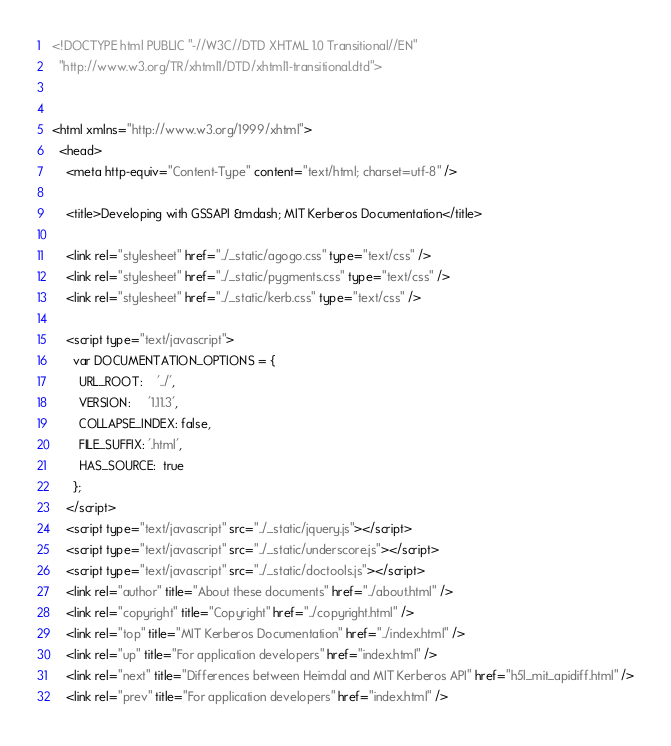Convert code to text. <code><loc_0><loc_0><loc_500><loc_500><_HTML_>

<!DOCTYPE html PUBLIC "-//W3C//DTD XHTML 1.0 Transitional//EN"
  "http://www.w3.org/TR/xhtml1/DTD/xhtml1-transitional.dtd">


<html xmlns="http://www.w3.org/1999/xhtml">
  <head>
    <meta http-equiv="Content-Type" content="text/html; charset=utf-8" />
    
    <title>Developing with GSSAPI &mdash; MIT Kerberos Documentation</title>
    
    <link rel="stylesheet" href="../_static/agogo.css" type="text/css" />
    <link rel="stylesheet" href="../_static/pygments.css" type="text/css" />
    <link rel="stylesheet" href="../_static/kerb.css" type="text/css" />
    
    <script type="text/javascript">
      var DOCUMENTATION_OPTIONS = {
        URL_ROOT:    '../',
        VERSION:     '1.11.3',
        COLLAPSE_INDEX: false,
        FILE_SUFFIX: '.html',
        HAS_SOURCE:  true
      };
    </script>
    <script type="text/javascript" src="../_static/jquery.js"></script>
    <script type="text/javascript" src="../_static/underscore.js"></script>
    <script type="text/javascript" src="../_static/doctools.js"></script>
    <link rel="author" title="About these documents" href="../about.html" />
    <link rel="copyright" title="Copyright" href="../copyright.html" />
    <link rel="top" title="MIT Kerberos Documentation" href="../index.html" />
    <link rel="up" title="For application developers" href="index.html" />
    <link rel="next" title="Differences between Heimdal and MIT Kerberos API" href="h5l_mit_apidiff.html" />
    <link rel="prev" title="For application developers" href="index.html" /> </code> 